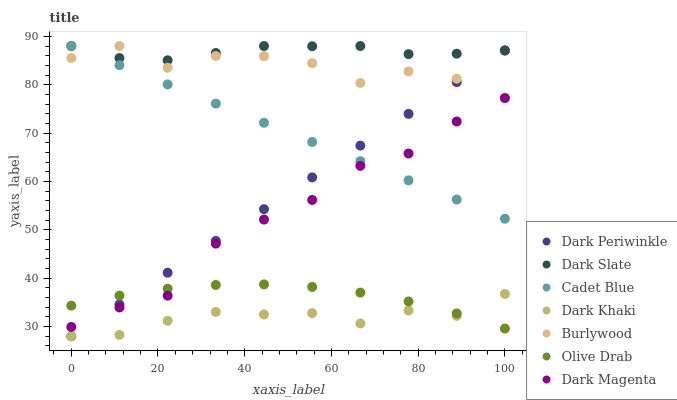Does Dark Khaki have the minimum area under the curve?
Answer yes or no. Yes. Does Dark Slate have the maximum area under the curve?
Answer yes or no. Yes. Does Dark Magenta have the minimum area under the curve?
Answer yes or no. No. Does Dark Magenta have the maximum area under the curve?
Answer yes or no. No. Is Cadet Blue the smoothest?
Answer yes or no. Yes. Is Burlywood the roughest?
Answer yes or no. Yes. Is Dark Magenta the smoothest?
Answer yes or no. No. Is Dark Magenta the roughest?
Answer yes or no. No. Does Dark Khaki have the lowest value?
Answer yes or no. Yes. Does Dark Magenta have the lowest value?
Answer yes or no. No. Does Dark Slate have the highest value?
Answer yes or no. Yes. Does Dark Magenta have the highest value?
Answer yes or no. No. Is Olive Drab less than Cadet Blue?
Answer yes or no. Yes. Is Dark Slate greater than Olive Drab?
Answer yes or no. Yes. Does Dark Magenta intersect Olive Drab?
Answer yes or no. Yes. Is Dark Magenta less than Olive Drab?
Answer yes or no. No. Is Dark Magenta greater than Olive Drab?
Answer yes or no. No. Does Olive Drab intersect Cadet Blue?
Answer yes or no. No. 